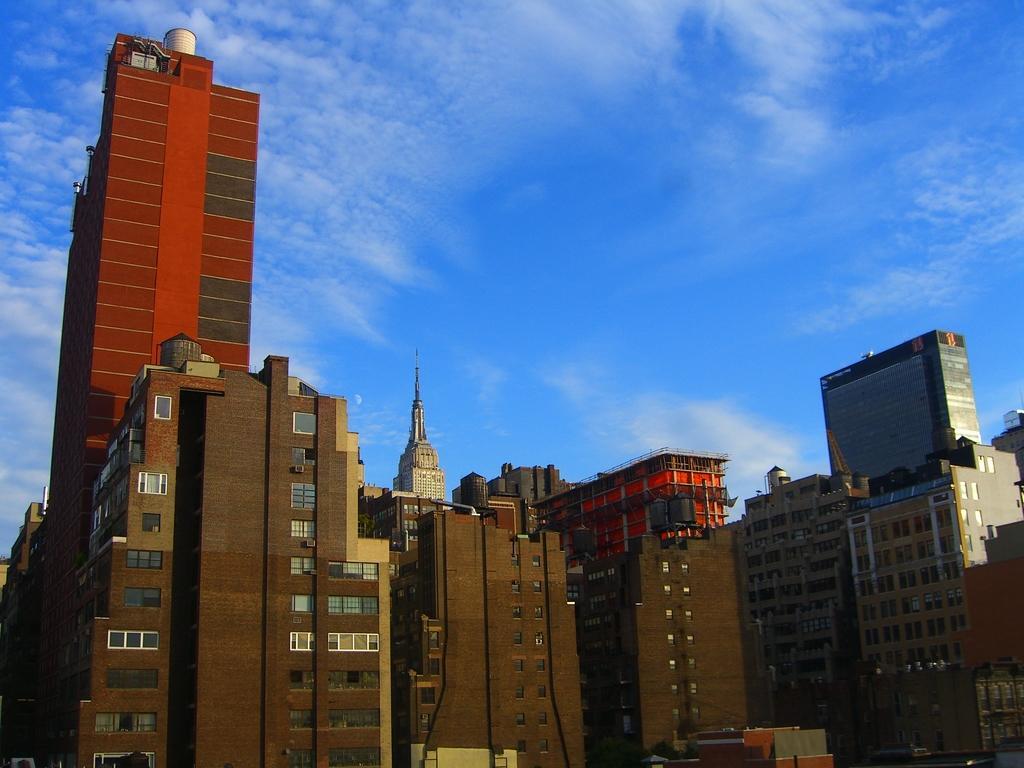Describe this image in one or two sentences. This picture is taken from outside of the building. In this image, we can see a building, tower, glass window. At the top, we can see a sky which is a bit cloudy. 